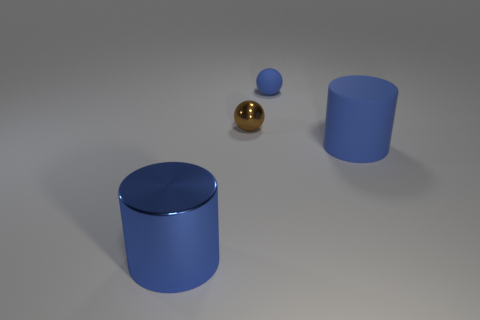Do the blue thing that is on the left side of the blue ball and the cylinder that is to the right of the big blue metal cylinder have the same material?
Make the answer very short. No. How many cylinders are either brown things or yellow things?
Your answer should be very brief. 0. There is a big blue cylinder in front of the cylinder right of the big blue metal object; what number of big blue cylinders are behind it?
Provide a short and direct response. 1. There is another thing that is the same shape as the big metal thing; what is it made of?
Your answer should be very brief. Rubber. There is a big object that is behind the blue metal cylinder; what is its color?
Keep it short and to the point. Blue. Is the small blue object made of the same material as the blue object that is in front of the big blue matte thing?
Your answer should be compact. No. What is the small brown ball made of?
Make the answer very short. Metal. What is the shape of the big blue object that is made of the same material as the small brown sphere?
Your answer should be compact. Cylinder. What number of other things are the same shape as the blue metallic thing?
Your answer should be very brief. 1. There is a tiny blue sphere; how many small blue matte balls are behind it?
Give a very brief answer. 0. 